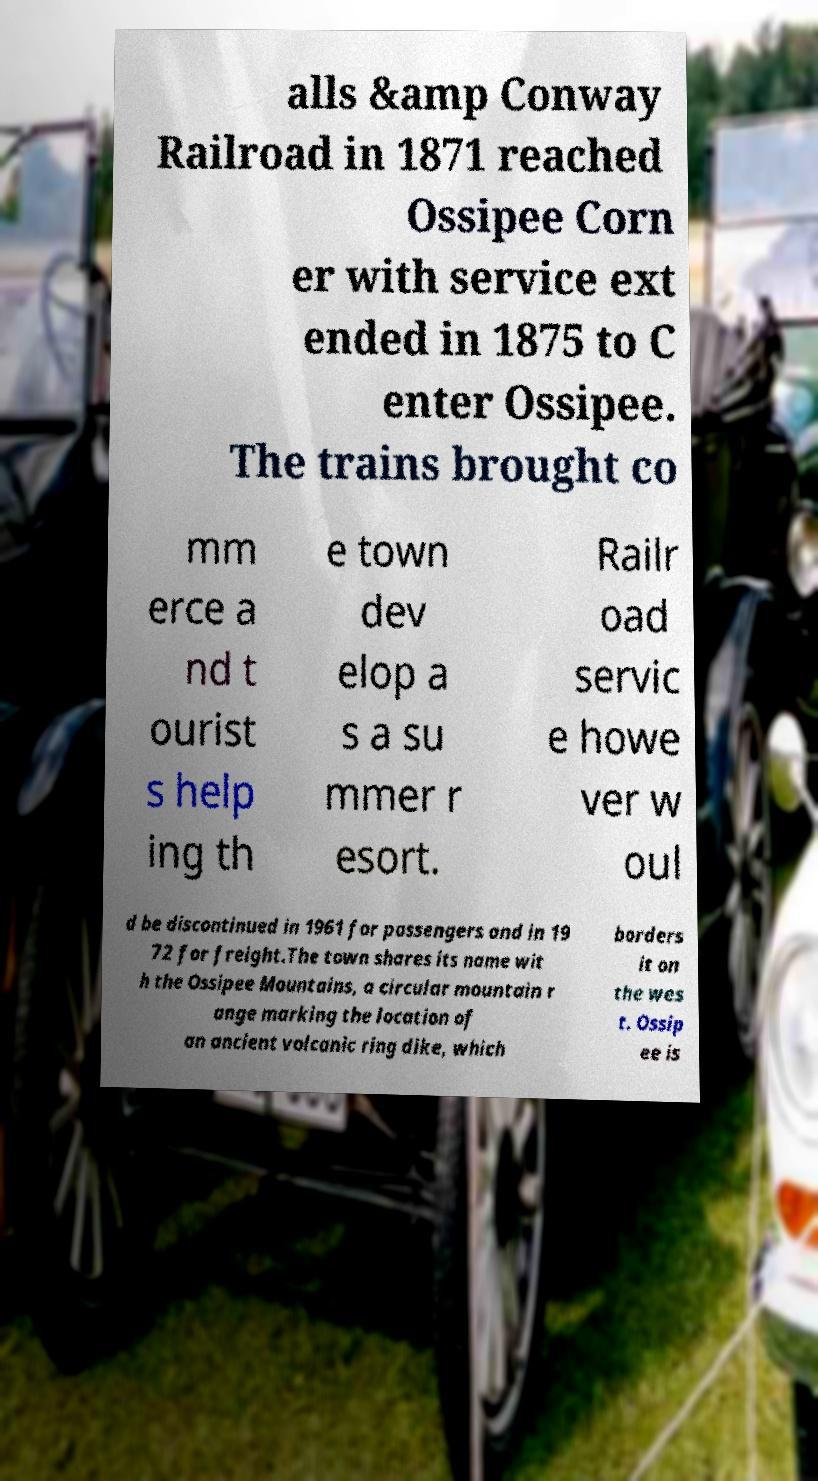Please identify and transcribe the text found in this image. alls &amp Conway Railroad in 1871 reached Ossipee Corn er with service ext ended in 1875 to C enter Ossipee. The trains brought co mm erce a nd t ourist s help ing th e town dev elop a s a su mmer r esort. Railr oad servic e howe ver w oul d be discontinued in 1961 for passengers and in 19 72 for freight.The town shares its name wit h the Ossipee Mountains, a circular mountain r ange marking the location of an ancient volcanic ring dike, which borders it on the wes t. Ossip ee is 